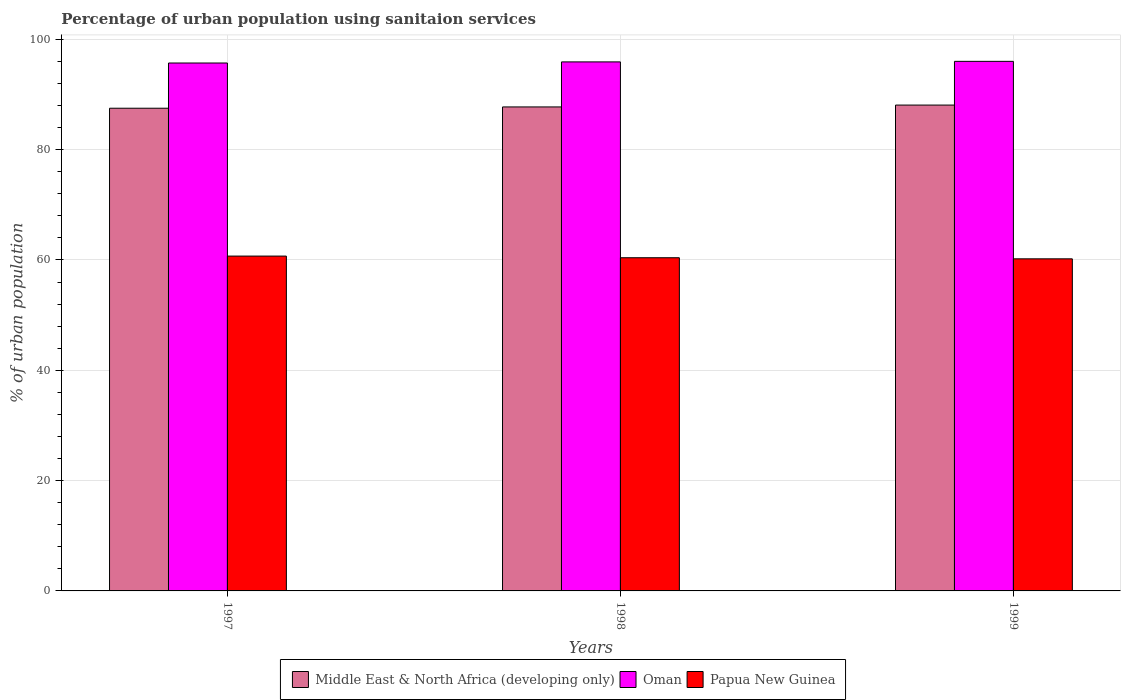Are the number of bars on each tick of the X-axis equal?
Give a very brief answer. Yes. How many bars are there on the 3rd tick from the left?
Offer a very short reply. 3. What is the percentage of urban population using sanitaion services in Middle East & North Africa (developing only) in 1998?
Ensure brevity in your answer.  87.74. Across all years, what is the maximum percentage of urban population using sanitaion services in Middle East & North Africa (developing only)?
Provide a succinct answer. 88.08. Across all years, what is the minimum percentage of urban population using sanitaion services in Papua New Guinea?
Provide a short and direct response. 60.2. What is the total percentage of urban population using sanitaion services in Papua New Guinea in the graph?
Make the answer very short. 181.3. What is the difference between the percentage of urban population using sanitaion services in Oman in 1998 and the percentage of urban population using sanitaion services in Papua New Guinea in 1999?
Offer a very short reply. 35.7. What is the average percentage of urban population using sanitaion services in Papua New Guinea per year?
Offer a terse response. 60.43. In the year 1997, what is the difference between the percentage of urban population using sanitaion services in Middle East & North Africa (developing only) and percentage of urban population using sanitaion services in Oman?
Ensure brevity in your answer.  -8.2. In how many years, is the percentage of urban population using sanitaion services in Oman greater than 64 %?
Make the answer very short. 3. What is the ratio of the percentage of urban population using sanitaion services in Papua New Guinea in 1998 to that in 1999?
Give a very brief answer. 1. Is the difference between the percentage of urban population using sanitaion services in Middle East & North Africa (developing only) in 1998 and 1999 greater than the difference between the percentage of urban population using sanitaion services in Oman in 1998 and 1999?
Make the answer very short. No. What is the difference between the highest and the second highest percentage of urban population using sanitaion services in Papua New Guinea?
Offer a very short reply. 0.3. What is the difference between the highest and the lowest percentage of urban population using sanitaion services in Papua New Guinea?
Provide a short and direct response. 0.5. What does the 2nd bar from the left in 1997 represents?
Keep it short and to the point. Oman. What does the 2nd bar from the right in 1998 represents?
Offer a terse response. Oman. How many bars are there?
Give a very brief answer. 9. Are all the bars in the graph horizontal?
Provide a short and direct response. No. Does the graph contain any zero values?
Your answer should be very brief. No. Where does the legend appear in the graph?
Provide a succinct answer. Bottom center. How many legend labels are there?
Your answer should be very brief. 3. What is the title of the graph?
Ensure brevity in your answer.  Percentage of urban population using sanitaion services. Does "Iceland" appear as one of the legend labels in the graph?
Provide a succinct answer. No. What is the label or title of the X-axis?
Your answer should be very brief. Years. What is the label or title of the Y-axis?
Your response must be concise. % of urban population. What is the % of urban population in Middle East & North Africa (developing only) in 1997?
Provide a succinct answer. 87.5. What is the % of urban population in Oman in 1997?
Make the answer very short. 95.7. What is the % of urban population in Papua New Guinea in 1997?
Ensure brevity in your answer.  60.7. What is the % of urban population in Middle East & North Africa (developing only) in 1998?
Your answer should be very brief. 87.74. What is the % of urban population in Oman in 1998?
Offer a terse response. 95.9. What is the % of urban population of Papua New Guinea in 1998?
Provide a short and direct response. 60.4. What is the % of urban population in Middle East & North Africa (developing only) in 1999?
Give a very brief answer. 88.08. What is the % of urban population in Oman in 1999?
Offer a terse response. 96. What is the % of urban population of Papua New Guinea in 1999?
Give a very brief answer. 60.2. Across all years, what is the maximum % of urban population of Middle East & North Africa (developing only)?
Your answer should be compact. 88.08. Across all years, what is the maximum % of urban population of Oman?
Give a very brief answer. 96. Across all years, what is the maximum % of urban population in Papua New Guinea?
Your answer should be compact. 60.7. Across all years, what is the minimum % of urban population of Middle East & North Africa (developing only)?
Provide a succinct answer. 87.5. Across all years, what is the minimum % of urban population of Oman?
Offer a very short reply. 95.7. Across all years, what is the minimum % of urban population of Papua New Guinea?
Provide a short and direct response. 60.2. What is the total % of urban population in Middle East & North Africa (developing only) in the graph?
Keep it short and to the point. 263.32. What is the total % of urban population in Oman in the graph?
Ensure brevity in your answer.  287.6. What is the total % of urban population of Papua New Guinea in the graph?
Offer a terse response. 181.3. What is the difference between the % of urban population in Middle East & North Africa (developing only) in 1997 and that in 1998?
Your response must be concise. -0.24. What is the difference between the % of urban population in Papua New Guinea in 1997 and that in 1998?
Provide a succinct answer. 0.3. What is the difference between the % of urban population of Middle East & North Africa (developing only) in 1997 and that in 1999?
Offer a terse response. -0.57. What is the difference between the % of urban population of Oman in 1997 and that in 1999?
Your answer should be very brief. -0.3. What is the difference between the % of urban population in Papua New Guinea in 1997 and that in 1999?
Make the answer very short. 0.5. What is the difference between the % of urban population in Middle East & North Africa (developing only) in 1998 and that in 1999?
Offer a very short reply. -0.34. What is the difference between the % of urban population in Oman in 1998 and that in 1999?
Your answer should be compact. -0.1. What is the difference between the % of urban population in Papua New Guinea in 1998 and that in 1999?
Provide a succinct answer. 0.2. What is the difference between the % of urban population in Middle East & North Africa (developing only) in 1997 and the % of urban population in Oman in 1998?
Your response must be concise. -8.4. What is the difference between the % of urban population in Middle East & North Africa (developing only) in 1997 and the % of urban population in Papua New Guinea in 1998?
Offer a very short reply. 27.1. What is the difference between the % of urban population in Oman in 1997 and the % of urban population in Papua New Guinea in 1998?
Provide a short and direct response. 35.3. What is the difference between the % of urban population in Middle East & North Africa (developing only) in 1997 and the % of urban population in Oman in 1999?
Your answer should be compact. -8.5. What is the difference between the % of urban population of Middle East & North Africa (developing only) in 1997 and the % of urban population of Papua New Guinea in 1999?
Your answer should be compact. 27.3. What is the difference between the % of urban population of Oman in 1997 and the % of urban population of Papua New Guinea in 1999?
Offer a terse response. 35.5. What is the difference between the % of urban population of Middle East & North Africa (developing only) in 1998 and the % of urban population of Oman in 1999?
Your answer should be compact. -8.26. What is the difference between the % of urban population of Middle East & North Africa (developing only) in 1998 and the % of urban population of Papua New Guinea in 1999?
Ensure brevity in your answer.  27.54. What is the difference between the % of urban population of Oman in 1998 and the % of urban population of Papua New Guinea in 1999?
Ensure brevity in your answer.  35.7. What is the average % of urban population in Middle East & North Africa (developing only) per year?
Offer a very short reply. 87.77. What is the average % of urban population in Oman per year?
Keep it short and to the point. 95.87. What is the average % of urban population of Papua New Guinea per year?
Keep it short and to the point. 60.43. In the year 1997, what is the difference between the % of urban population in Middle East & North Africa (developing only) and % of urban population in Oman?
Provide a succinct answer. -8.2. In the year 1997, what is the difference between the % of urban population in Middle East & North Africa (developing only) and % of urban population in Papua New Guinea?
Your answer should be compact. 26.8. In the year 1997, what is the difference between the % of urban population in Oman and % of urban population in Papua New Guinea?
Your response must be concise. 35. In the year 1998, what is the difference between the % of urban population of Middle East & North Africa (developing only) and % of urban population of Oman?
Offer a terse response. -8.16. In the year 1998, what is the difference between the % of urban population in Middle East & North Africa (developing only) and % of urban population in Papua New Guinea?
Offer a terse response. 27.34. In the year 1998, what is the difference between the % of urban population of Oman and % of urban population of Papua New Guinea?
Give a very brief answer. 35.5. In the year 1999, what is the difference between the % of urban population in Middle East & North Africa (developing only) and % of urban population in Oman?
Offer a terse response. -7.92. In the year 1999, what is the difference between the % of urban population of Middle East & North Africa (developing only) and % of urban population of Papua New Guinea?
Give a very brief answer. 27.88. In the year 1999, what is the difference between the % of urban population in Oman and % of urban population in Papua New Guinea?
Offer a very short reply. 35.8. What is the ratio of the % of urban population in Middle East & North Africa (developing only) in 1997 to that in 1999?
Offer a very short reply. 0.99. What is the ratio of the % of urban population in Oman in 1997 to that in 1999?
Keep it short and to the point. 1. What is the ratio of the % of urban population of Papua New Guinea in 1997 to that in 1999?
Your answer should be compact. 1.01. What is the difference between the highest and the second highest % of urban population in Middle East & North Africa (developing only)?
Ensure brevity in your answer.  0.34. What is the difference between the highest and the second highest % of urban population of Oman?
Give a very brief answer. 0.1. What is the difference between the highest and the second highest % of urban population of Papua New Guinea?
Make the answer very short. 0.3. What is the difference between the highest and the lowest % of urban population in Middle East & North Africa (developing only)?
Make the answer very short. 0.57. What is the difference between the highest and the lowest % of urban population in Oman?
Ensure brevity in your answer.  0.3. What is the difference between the highest and the lowest % of urban population of Papua New Guinea?
Your response must be concise. 0.5. 